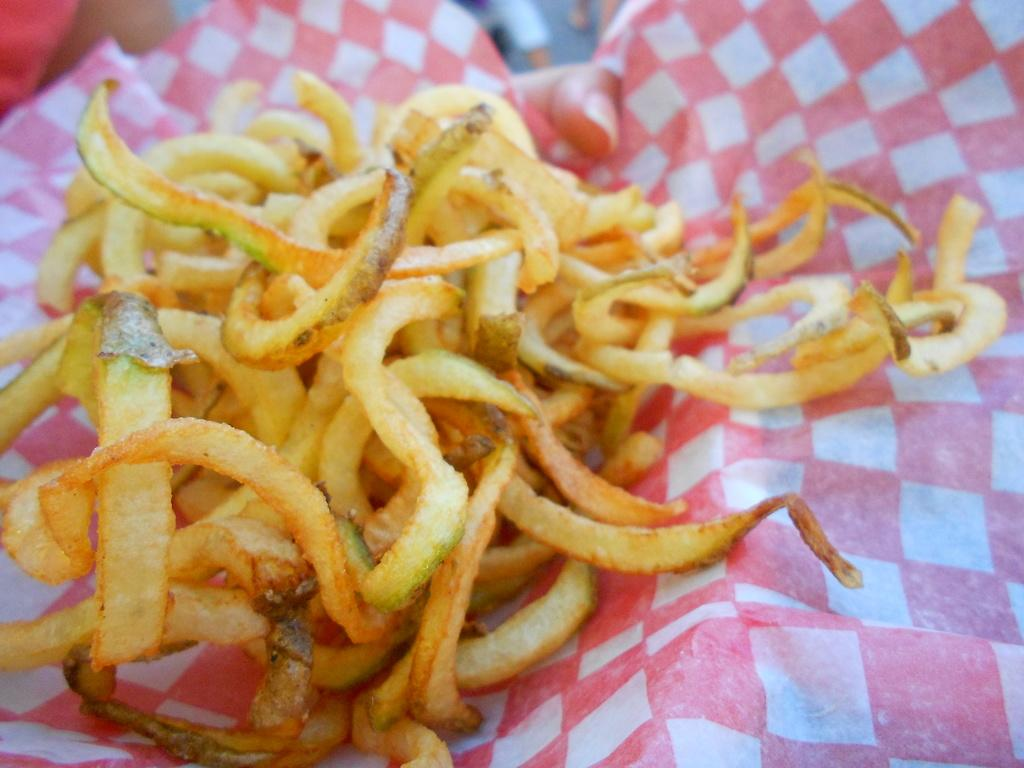What is the main subject of the image? There is a food item in the image. How is the food item placed in the image? The food item is on an oil paper. Can you describe the oil paper in the image? The oil paper has a design of squares, and the squares are pink and white in color. Is there a boy holding an apple in the image? There is no boy or apple present in the image. The image only features a food item placed on an oil paper with a pink and white square design. 